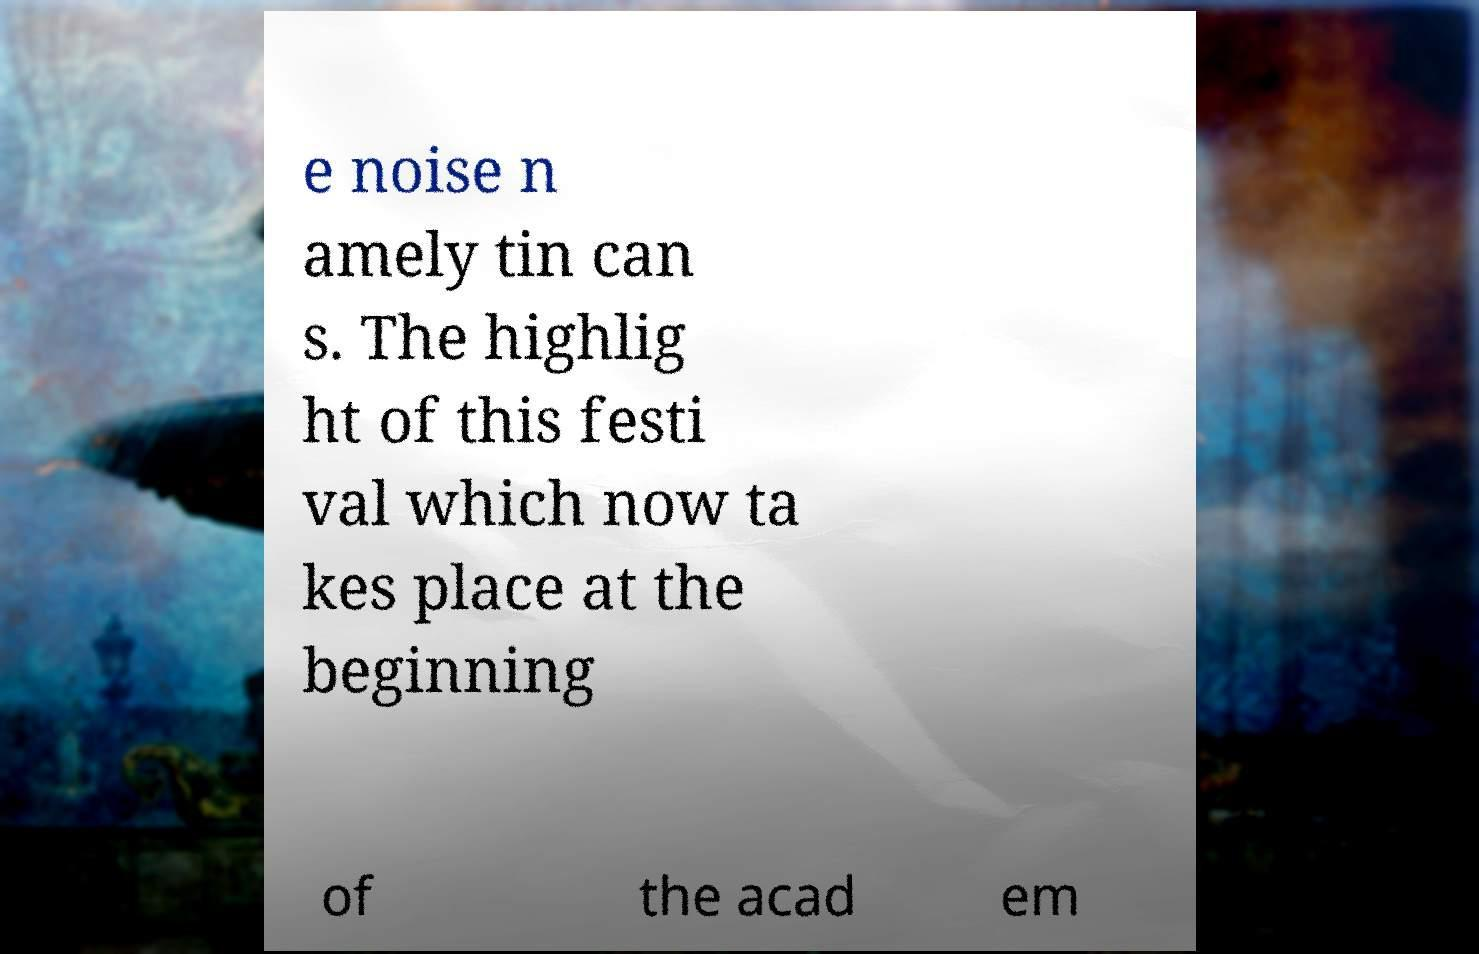Could you assist in decoding the text presented in this image and type it out clearly? e noise n amely tin can s. The highlig ht of this festi val which now ta kes place at the beginning of the acad em 